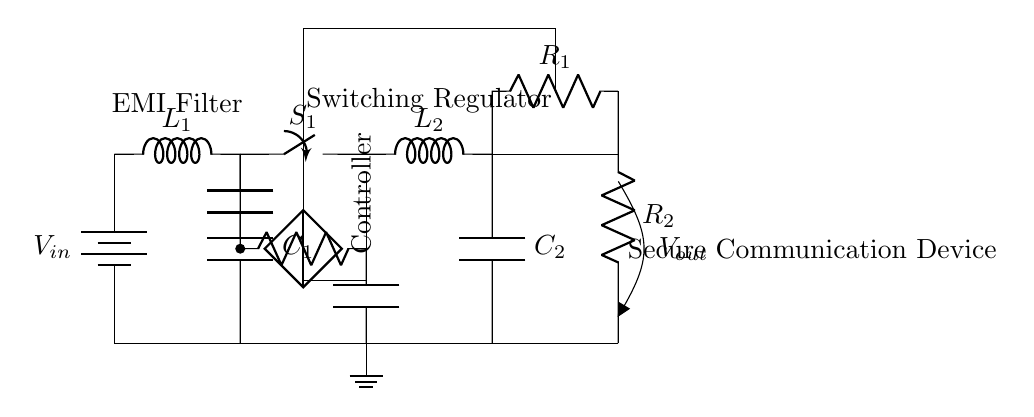What is the input component of the circuit? The input component is the battery, which provides the voltage needed for the circuit to operate. It is clearly labeled as V_in in the diagram.
Answer: Battery What type of filter is present at the beginning of the circuit? An EMI filter is present at the beginning of the circuit, serving to suppress electromagnetic interference before the voltage reaches the regulator. It consists of an inductor and capacitors.
Answer: EMI filter How many inductors are there in the circuit? There are two inductors in the circuit, one labeled as L1 for the input filter and another labeled as L2 for the switching regulator stage.
Answer: Two What role does the controlled voltage source play in the circuit? The controlled voltage source acts as a controller regulating the output voltage based on feedback from the circuit, ensuring that the desired voltage output is maintained for the secure communication device.
Answer: Regulation What is the purpose of the capacitor connected to the output side of the regulator? The output capacitor, labeled C2, smooths out the voltage at the output, ensuring that the output voltage remains stable and free from fluctuations that may be caused by the switching action of the regulator.
Answer: Smoothing What is the output voltage label in this circuit? The output voltage is labeled as V_out, which indicates the voltage level that is provided to the secure communication device from the regulator circuit.
Answer: V_out 